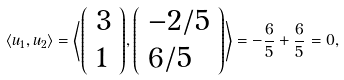<formula> <loc_0><loc_0><loc_500><loc_500>\langle u _ { 1 } , u _ { 2 } \rangle = \left \langle { \left ( \begin{array} { l } { 3 } \\ { 1 } \end{array} \right ) } , { \left ( \begin{array} { l } { - 2 / 5 } \\ { 6 / 5 } \end{array} \right ) } \right \rangle = - { \frac { 6 } { 5 } } + { \frac { 6 } { 5 } } = 0 ,</formula> 